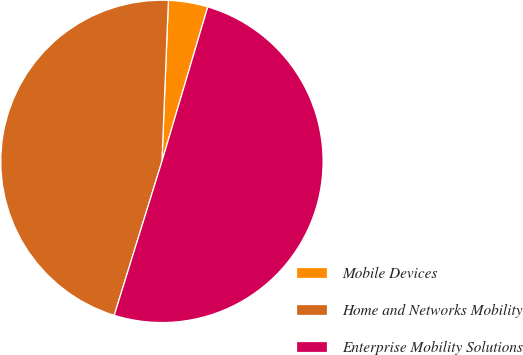Convert chart to OTSL. <chart><loc_0><loc_0><loc_500><loc_500><pie_chart><fcel>Mobile Devices<fcel>Home and Networks Mobility<fcel>Enterprise Mobility Solutions<nl><fcel>3.95%<fcel>45.85%<fcel>50.19%<nl></chart> 